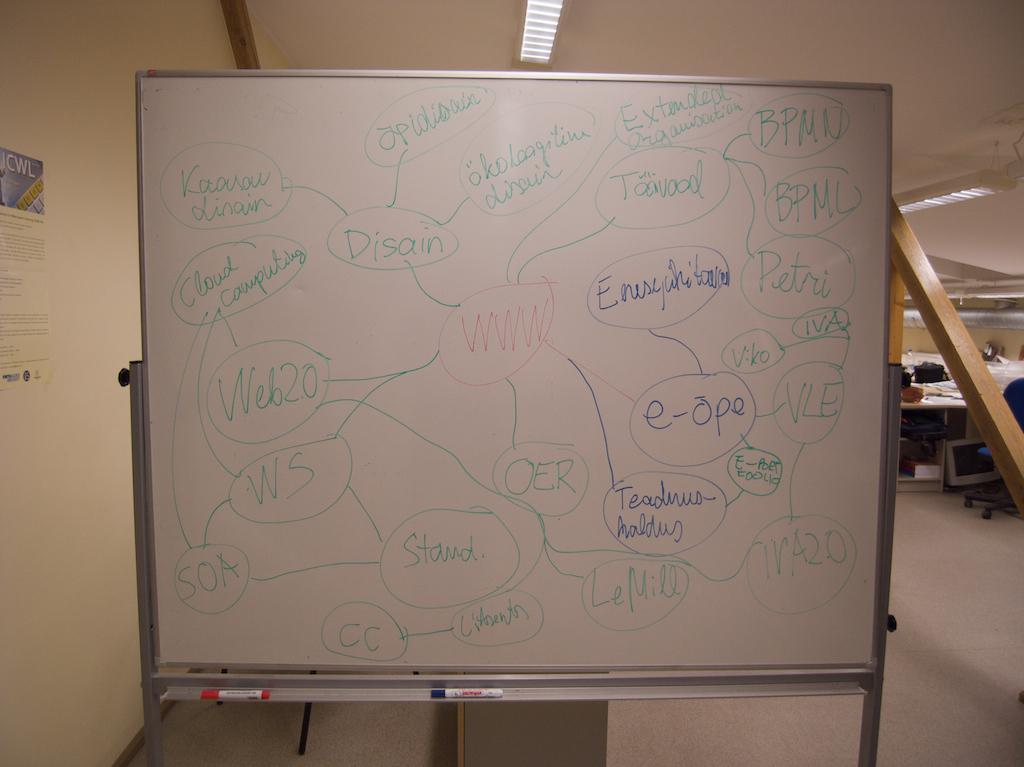Provide a one-sentence caption for the provided image. a white board with the red word WWW circled in the middle. 